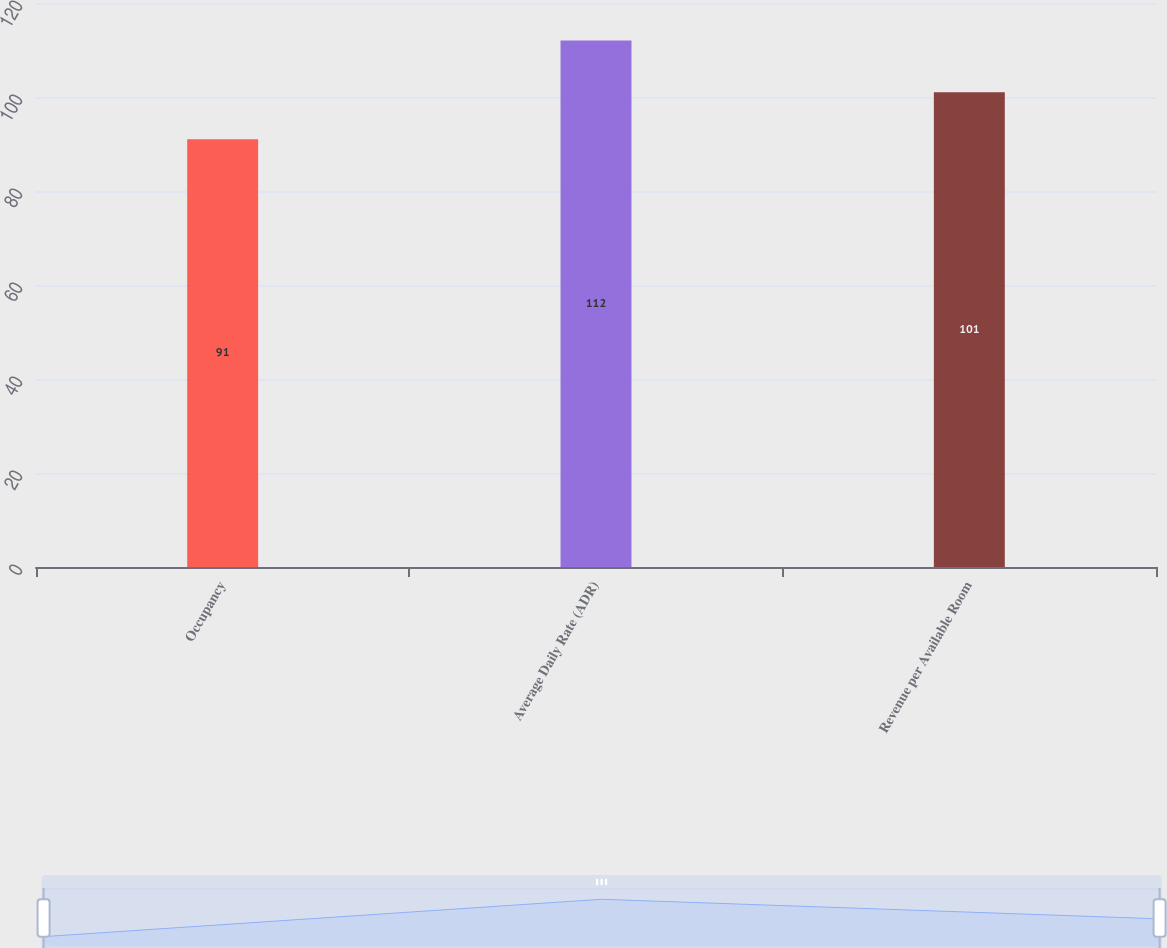Convert chart. <chart><loc_0><loc_0><loc_500><loc_500><bar_chart><fcel>Occupancy<fcel>Average Daily Rate (ADR)<fcel>Revenue per Available Room<nl><fcel>91<fcel>112<fcel>101<nl></chart> 